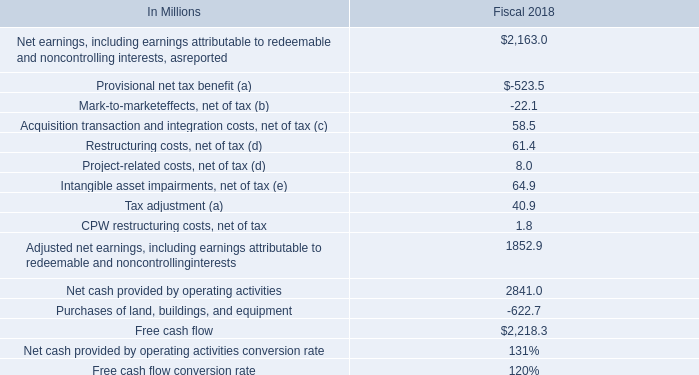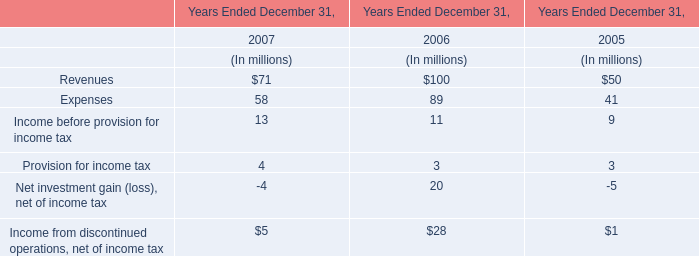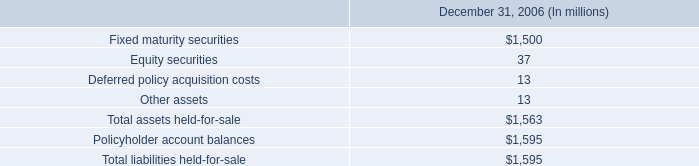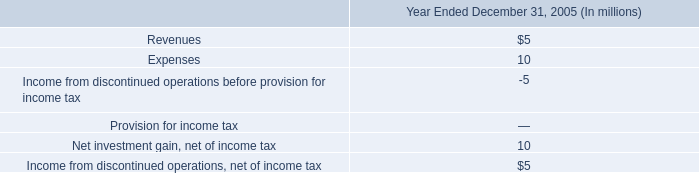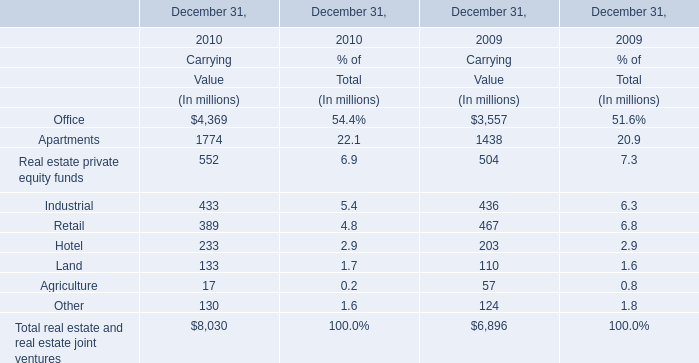What was the total amount of Carrying Value in 2010? (in million) 
Computations: ((((((((4369 + 1774) + 552) + 433) + 389) + 233) + 133) + 130) + 17)
Answer: 8030.0. 